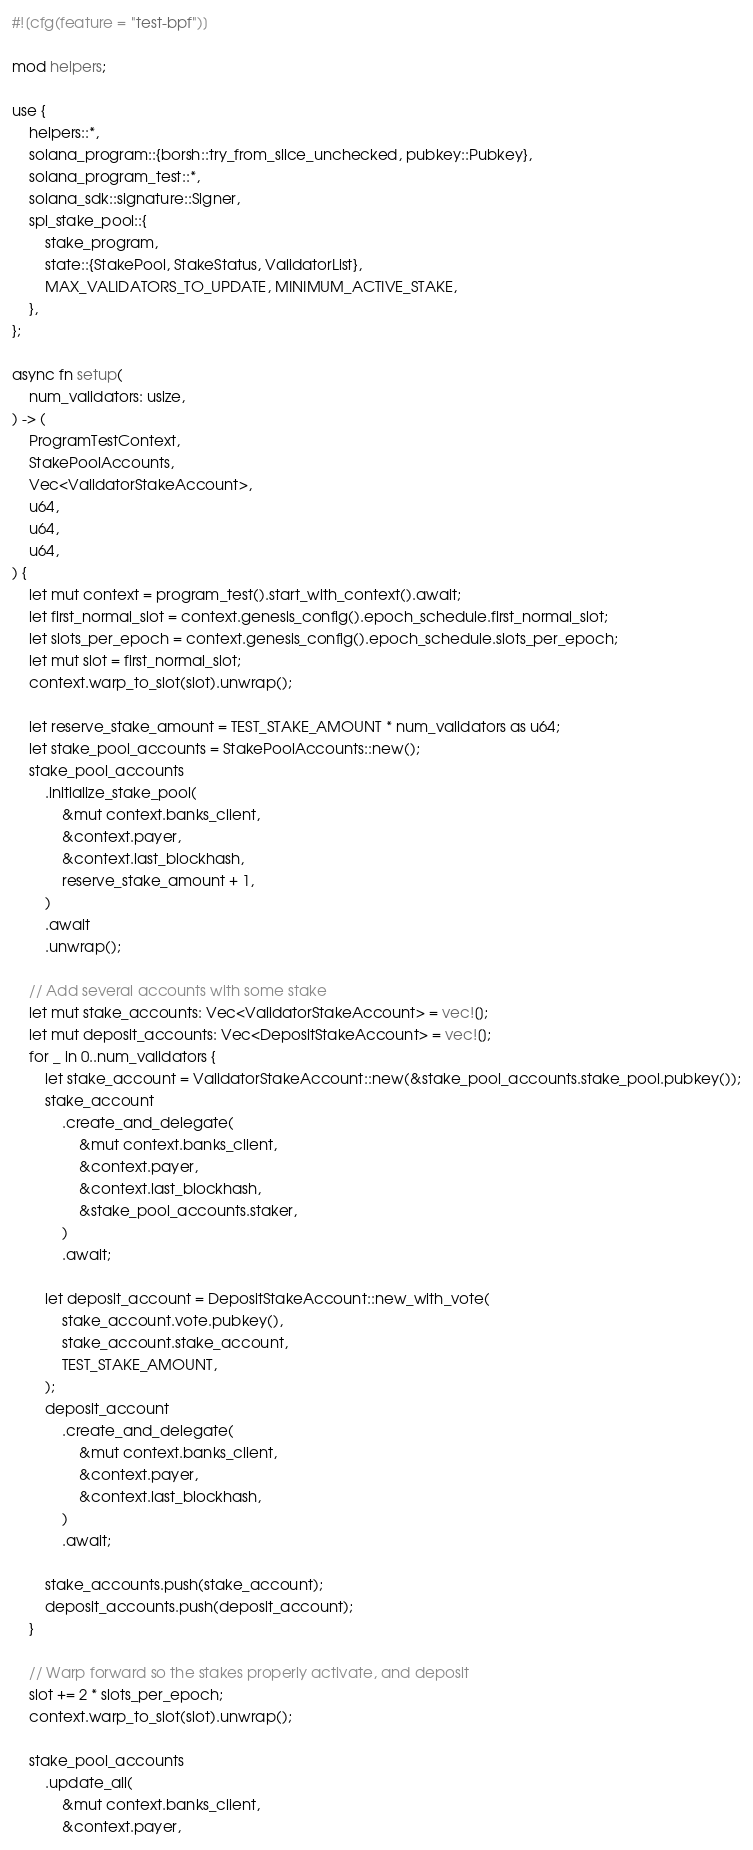Convert code to text. <code><loc_0><loc_0><loc_500><loc_500><_Rust_>#![cfg(feature = "test-bpf")]

mod helpers;

use {
    helpers::*,
    solana_program::{borsh::try_from_slice_unchecked, pubkey::Pubkey},
    solana_program_test::*,
    solana_sdk::signature::Signer,
    spl_stake_pool::{
        stake_program,
        state::{StakePool, StakeStatus, ValidatorList},
        MAX_VALIDATORS_TO_UPDATE, MINIMUM_ACTIVE_STAKE,
    },
};

async fn setup(
    num_validators: usize,
) -> (
    ProgramTestContext,
    StakePoolAccounts,
    Vec<ValidatorStakeAccount>,
    u64,
    u64,
    u64,
) {
    let mut context = program_test().start_with_context().await;
    let first_normal_slot = context.genesis_config().epoch_schedule.first_normal_slot;
    let slots_per_epoch = context.genesis_config().epoch_schedule.slots_per_epoch;
    let mut slot = first_normal_slot;
    context.warp_to_slot(slot).unwrap();

    let reserve_stake_amount = TEST_STAKE_AMOUNT * num_validators as u64;
    let stake_pool_accounts = StakePoolAccounts::new();
    stake_pool_accounts
        .initialize_stake_pool(
            &mut context.banks_client,
            &context.payer,
            &context.last_blockhash,
            reserve_stake_amount + 1,
        )
        .await
        .unwrap();

    // Add several accounts with some stake
    let mut stake_accounts: Vec<ValidatorStakeAccount> = vec![];
    let mut deposit_accounts: Vec<DepositStakeAccount> = vec![];
    for _ in 0..num_validators {
        let stake_account = ValidatorStakeAccount::new(&stake_pool_accounts.stake_pool.pubkey());
        stake_account
            .create_and_delegate(
                &mut context.banks_client,
                &context.payer,
                &context.last_blockhash,
                &stake_pool_accounts.staker,
            )
            .await;

        let deposit_account = DepositStakeAccount::new_with_vote(
            stake_account.vote.pubkey(),
            stake_account.stake_account,
            TEST_STAKE_AMOUNT,
        );
        deposit_account
            .create_and_delegate(
                &mut context.banks_client,
                &context.payer,
                &context.last_blockhash,
            )
            .await;

        stake_accounts.push(stake_account);
        deposit_accounts.push(deposit_account);
    }

    // Warp forward so the stakes properly activate, and deposit
    slot += 2 * slots_per_epoch;
    context.warp_to_slot(slot).unwrap();

    stake_pool_accounts
        .update_all(
            &mut context.banks_client,
            &context.payer,</code> 